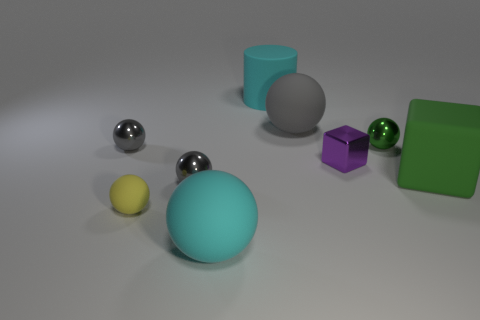Subtract all cyan cylinders. How many gray spheres are left? 3 Subtract all green metal balls. How many balls are left? 5 Subtract all green spheres. How many spheres are left? 5 Subtract all yellow balls. Subtract all green cubes. How many balls are left? 5 Subtract all cylinders. How many objects are left? 8 Add 7 tiny cubes. How many tiny cubes exist? 8 Subtract 0 red cubes. How many objects are left? 9 Subtract all yellow balls. Subtract all metallic things. How many objects are left? 4 Add 9 yellow rubber things. How many yellow rubber things are left? 10 